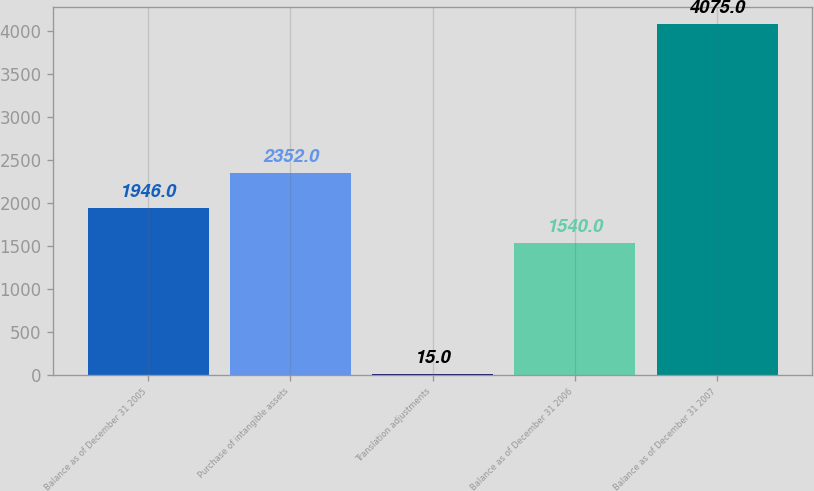Convert chart. <chart><loc_0><loc_0><loc_500><loc_500><bar_chart><fcel>Balance as of December 31 2005<fcel>Purchase of intangible assets<fcel>Translation adjustments<fcel>Balance as of December 31 2006<fcel>Balance as of December 31 2007<nl><fcel>1946<fcel>2352<fcel>15<fcel>1540<fcel>4075<nl></chart> 